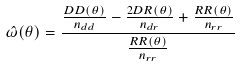Convert formula to latex. <formula><loc_0><loc_0><loc_500><loc_500>\hat { \omega } ( \theta ) = \frac { \frac { D D ( \theta ) } { n _ { d d } } - \frac { 2 D R ( \theta ) } { n _ { d r } } + \frac { R R ( \theta ) } { n _ { r r } } } { \frac { R R ( \theta ) } { n _ { r r } } }</formula> 